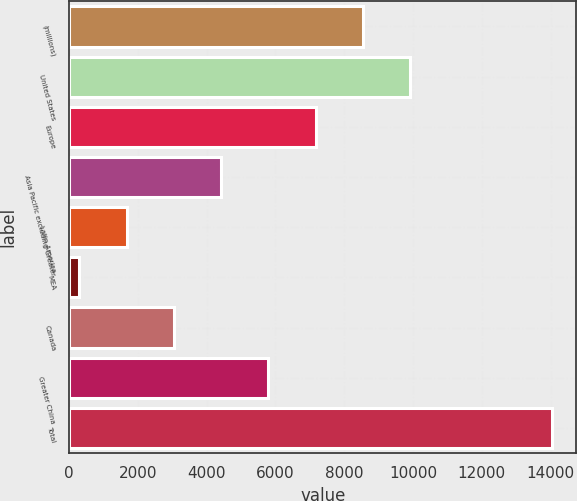<chart> <loc_0><loc_0><loc_500><loc_500><bar_chart><fcel>(millions)<fcel>United States<fcel>Europe<fcel>Asia Pacific excluding Greater<fcel>Latin America<fcel>MEA<fcel>Canada<fcel>Greater China<fcel>Total<nl><fcel>8549.2<fcel>9924.6<fcel>7173.8<fcel>4423<fcel>1672.2<fcel>296.8<fcel>3047.6<fcel>5798.4<fcel>14050.8<nl></chart> 